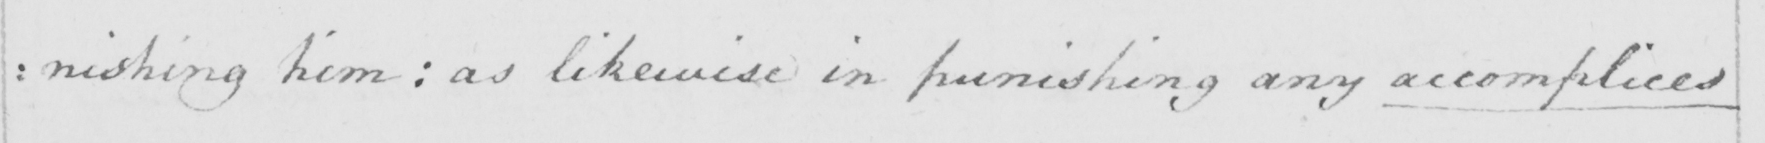What does this handwritten line say? :nishing him : as likewise in punishing any accomplices 